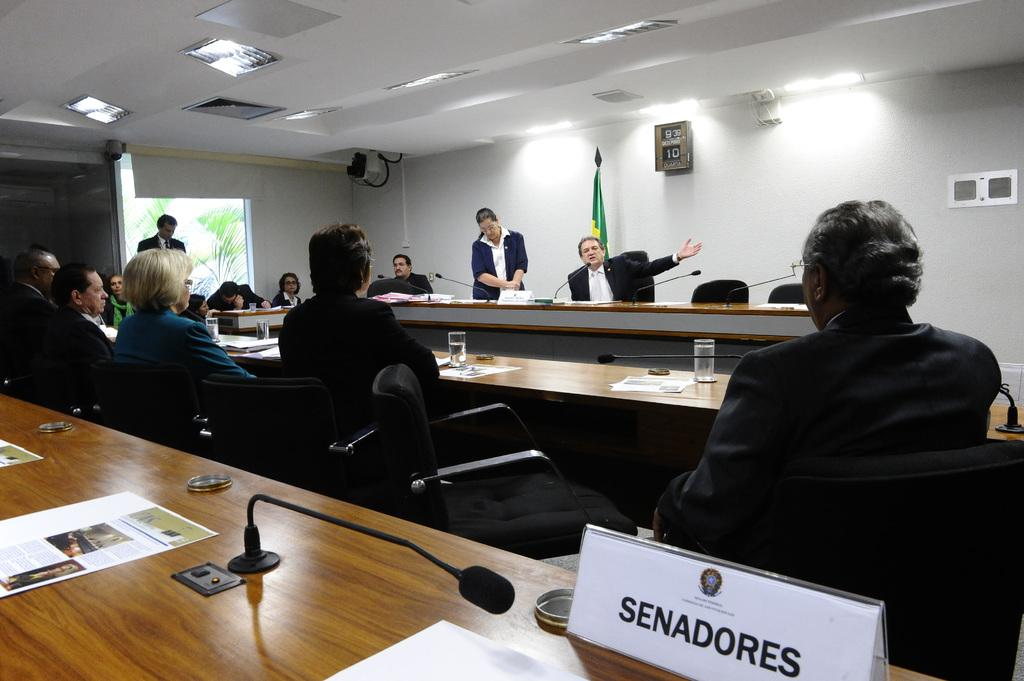Provide a one-sentence caption for the provided image. A man sits looking a speaker with a sign saying Senadores behind him. 